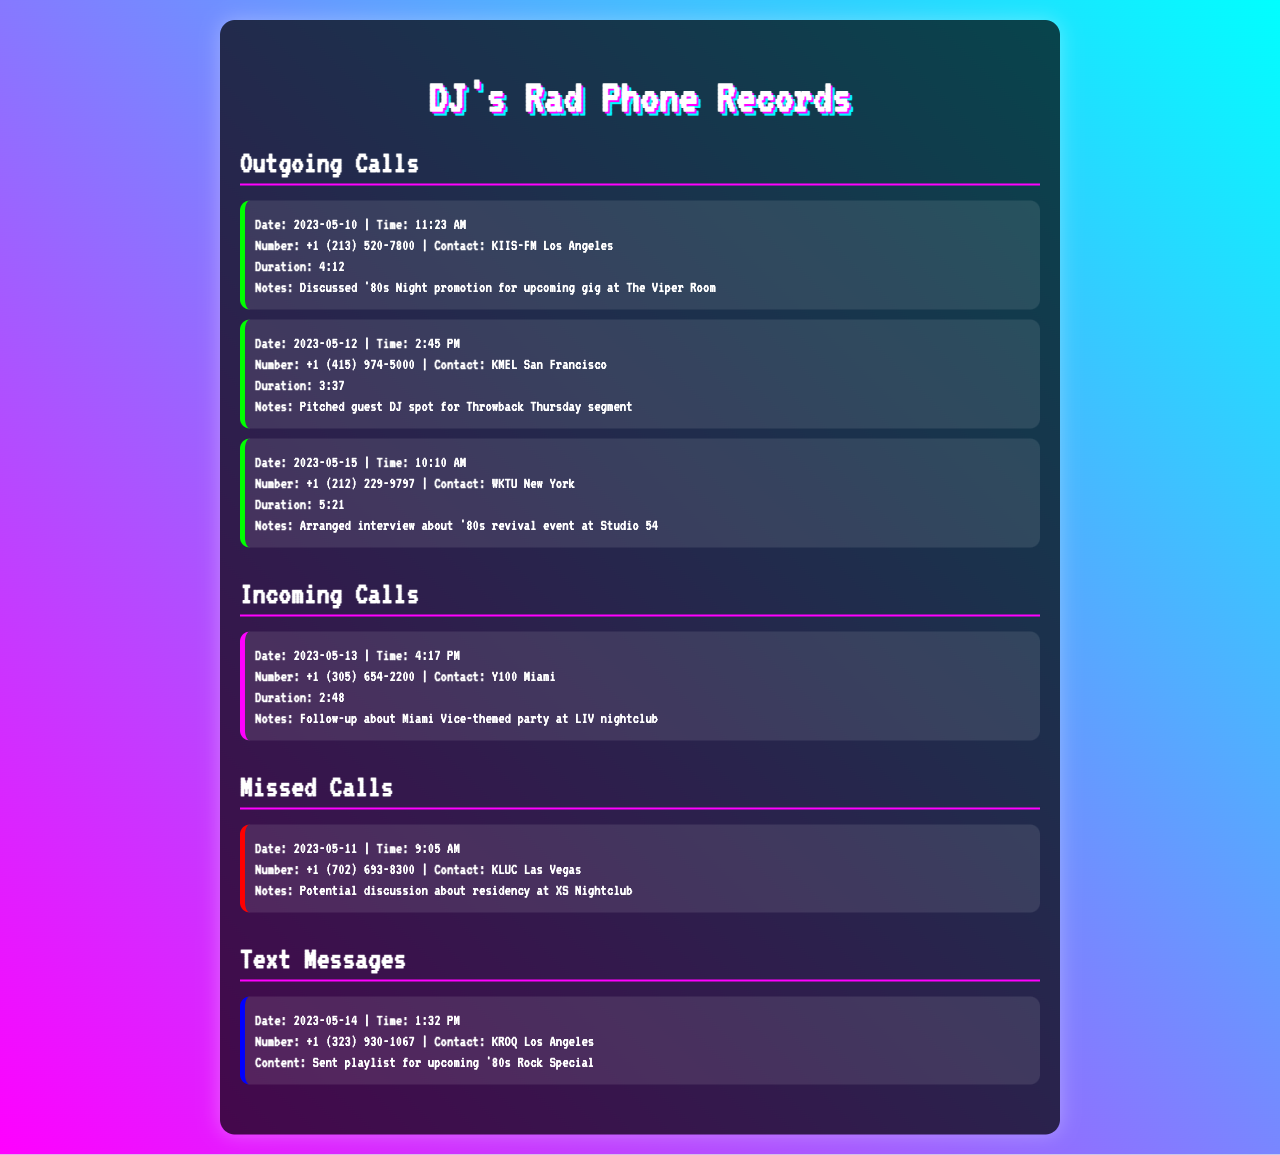what was the date of the call to KIIS-FM Los Angeles? The call to KIIS-FM Los Angeles occurred on 2023-05-10 as indicated in the document.
Answer: 2023-05-10 how long was the call to KMEL San Francisco? The duration of the call to KMEL San Francisco was 3 minutes and 37 seconds, as noted in the call record.
Answer: 3:37 who is the contact for the missed call from KLUC Las Vegas? The contact for the missed call from KLUC Las Vegas is not specified, but it's noted in the document.
Answer: KLUC Las Vegas what was discussed during the call to WKTU New York? The notes indicate that the discussion was about arranging an interview regarding an '80s revival event.
Answer: Interview about '80s revival event which radio station called on 2023-05-13? The radio station that called on this date was Y100 Miami.
Answer: Y100 Miami how many outgoing calls are listed in the document? The document lists a total of three outgoing calls.
Answer: 3 what was the primary purpose of the text message to KROQ Los Angeles? The text message content states it was to send a playlist for an upcoming special.
Answer: Send playlist which city is associated with the radio station KMEL? The document specifies that KMEL is located in San Francisco.
Answer: San Francisco what was the time of the incoming call from Y100 Miami? The call was received at 4:17 PM as detailed in the document.
Answer: 4:17 PM 